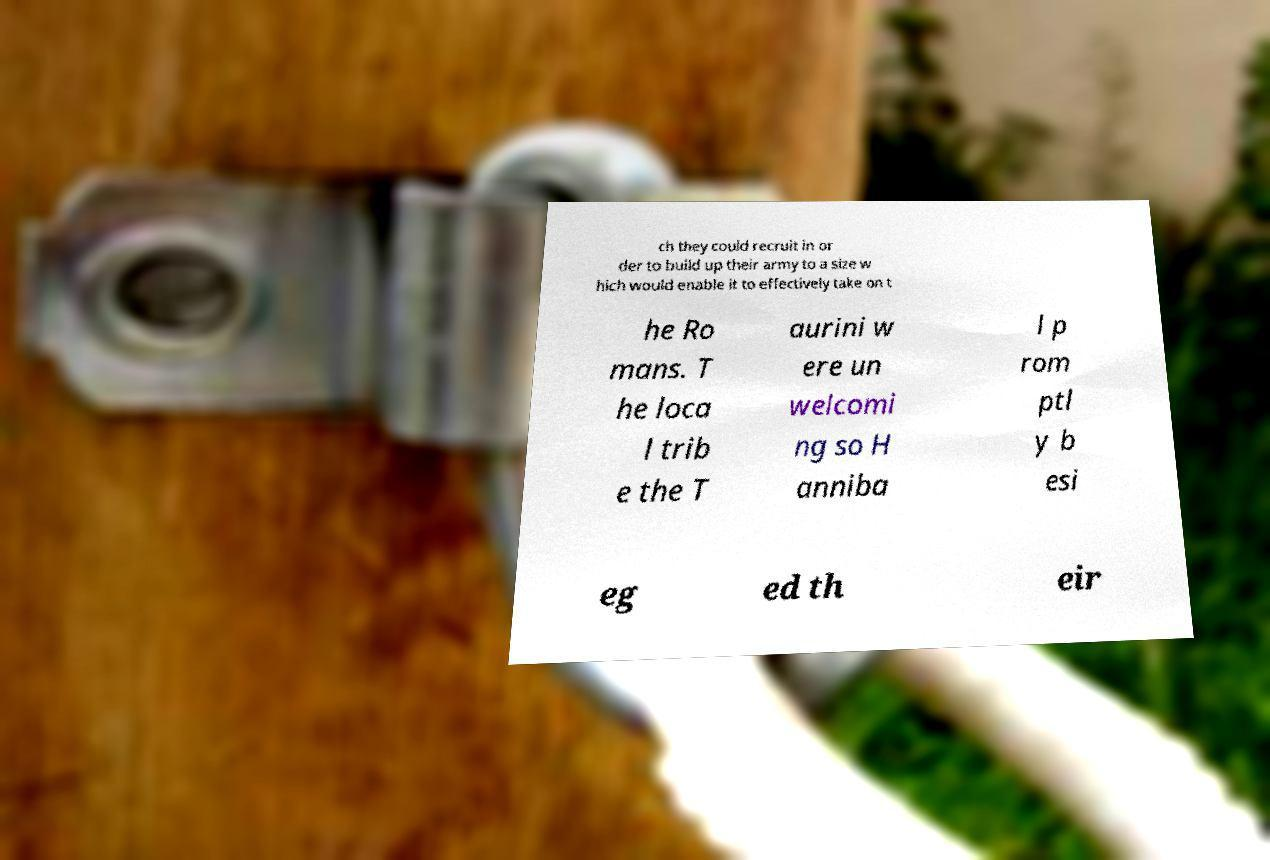I need the written content from this picture converted into text. Can you do that? ch they could recruit in or der to build up their army to a size w hich would enable it to effectively take on t he Ro mans. T he loca l trib e the T aurini w ere un welcomi ng so H anniba l p rom ptl y b esi eg ed th eir 